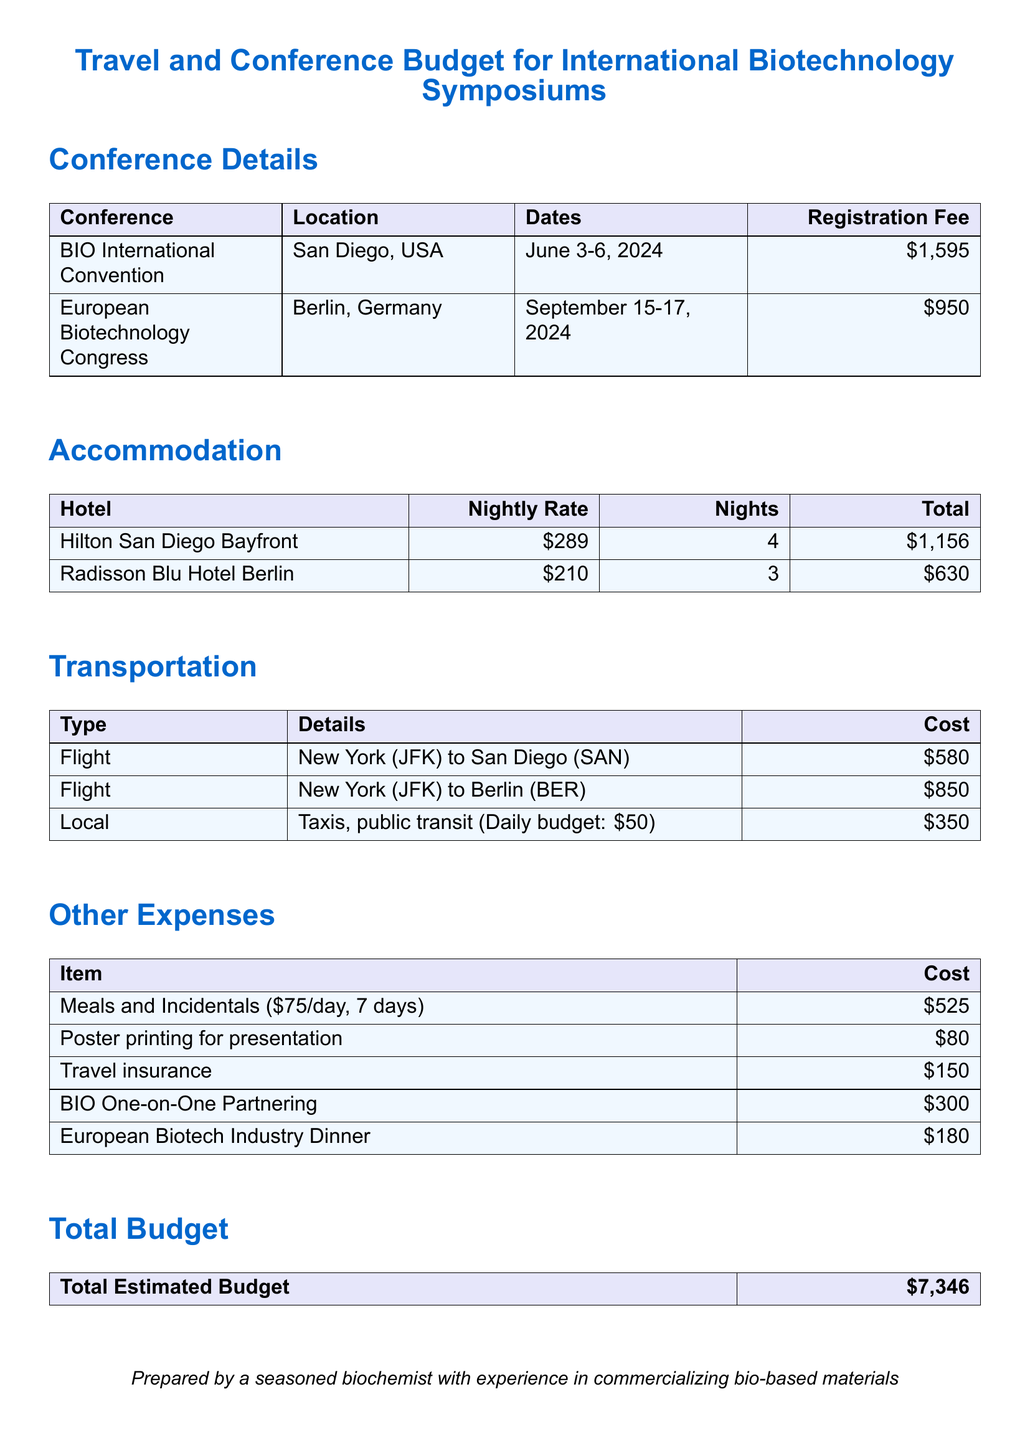What are the dates for the BIO International Convention? The dates are specifically stated as June 3-6, 2024, in the document.
Answer: June 3-6, 2024 What is the registration fee for the European Biotechnology Congress? The registration fee for this congress is clearly listed as $950 in the document.
Answer: $950 What is the nightly rate for accommodation at the Hilton San Diego Bayfront? The document specifies the nightly rate for this hotel as $289.
Answer: $289 How many nights will be spent at the Radisson Blu Hotel Berlin? The document indicates that 3 nights will be spent at this hotel.
Answer: 3 What is the total estimated budget for the trip? The total estimated budget is calculated and presented at the end of the document as $7,346.
Answer: $7,346 How much does the local transportation budget amount to? The cost for local transportation is listed as $350 in the document.
Answer: $350 What are the total meal expenses for the trip? The meals and incidentals section totals to $525, as shown in the document.
Answer: $525 What is the cost for the Travel insurance? The document indicates that travel insurance costs $150.
Answer: $150 What is the cost of the BIO One-on-One Partnering? The document specifies that the cost for this service is $300.
Answer: $300 